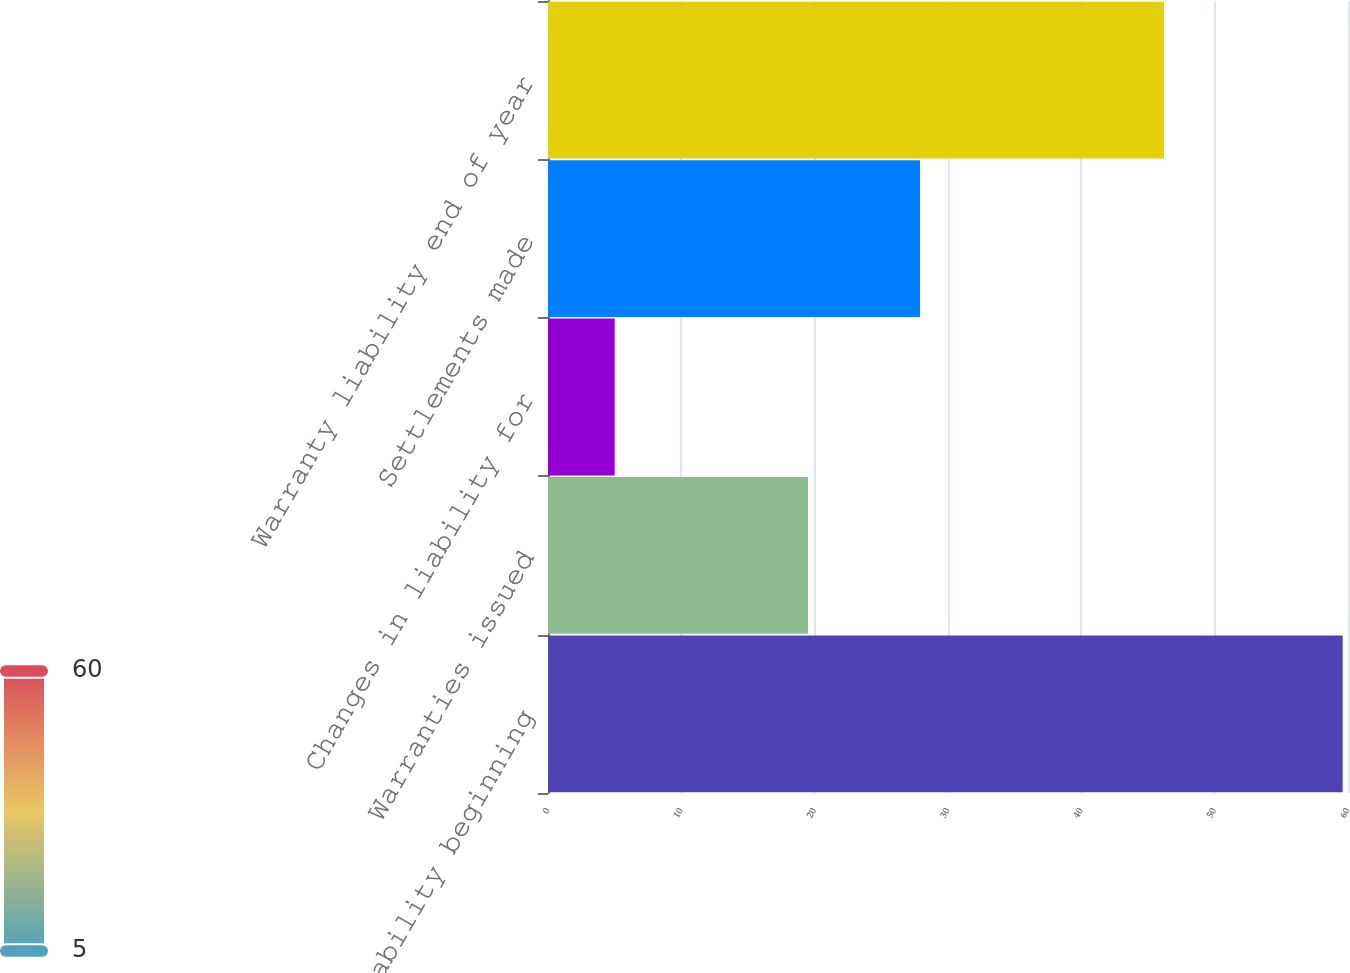Convert chart. <chart><loc_0><loc_0><loc_500><loc_500><bar_chart><fcel>Warranty liability beginning<fcel>Warranties issued<fcel>Changes in liability for<fcel>Settlements made<fcel>Warranty liability end of year<nl><fcel>59.6<fcel>19.5<fcel>5<fcel>27.9<fcel>46.2<nl></chart> 